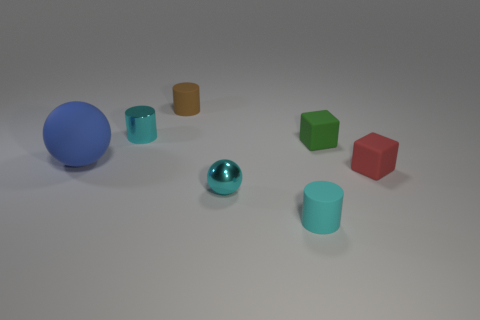Subtract all cyan cylinders. How many cylinders are left? 1 Add 3 tiny brown matte cylinders. How many objects exist? 10 Subtract all blue spheres. How many spheres are left? 1 Subtract all red balls. How many cyan cylinders are left? 2 Subtract all cylinders. How many objects are left? 4 Subtract 2 blocks. How many blocks are left? 0 Subtract all brown matte objects. Subtract all big yellow blocks. How many objects are left? 6 Add 1 large blue rubber objects. How many large blue rubber objects are left? 2 Add 1 large yellow metal blocks. How many large yellow metal blocks exist? 1 Subtract 1 red blocks. How many objects are left? 6 